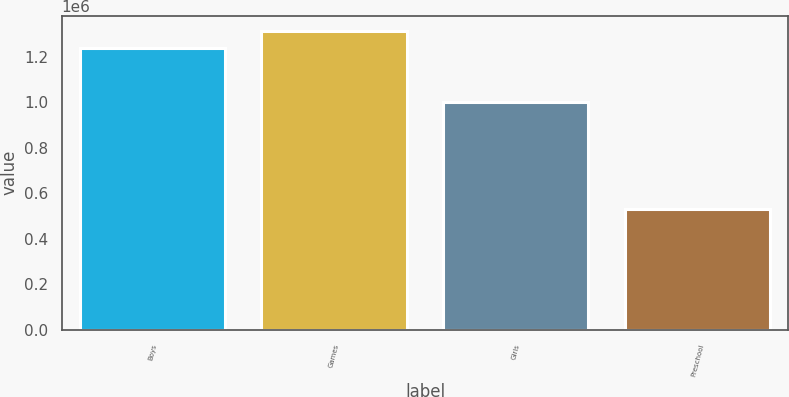<chart> <loc_0><loc_0><loc_500><loc_500><bar_chart><fcel>Boys<fcel>Games<fcel>Girls<fcel>Preschool<nl><fcel>1.23761e+06<fcel>1.31557e+06<fcel>1.0017e+06<fcel>531637<nl></chart> 